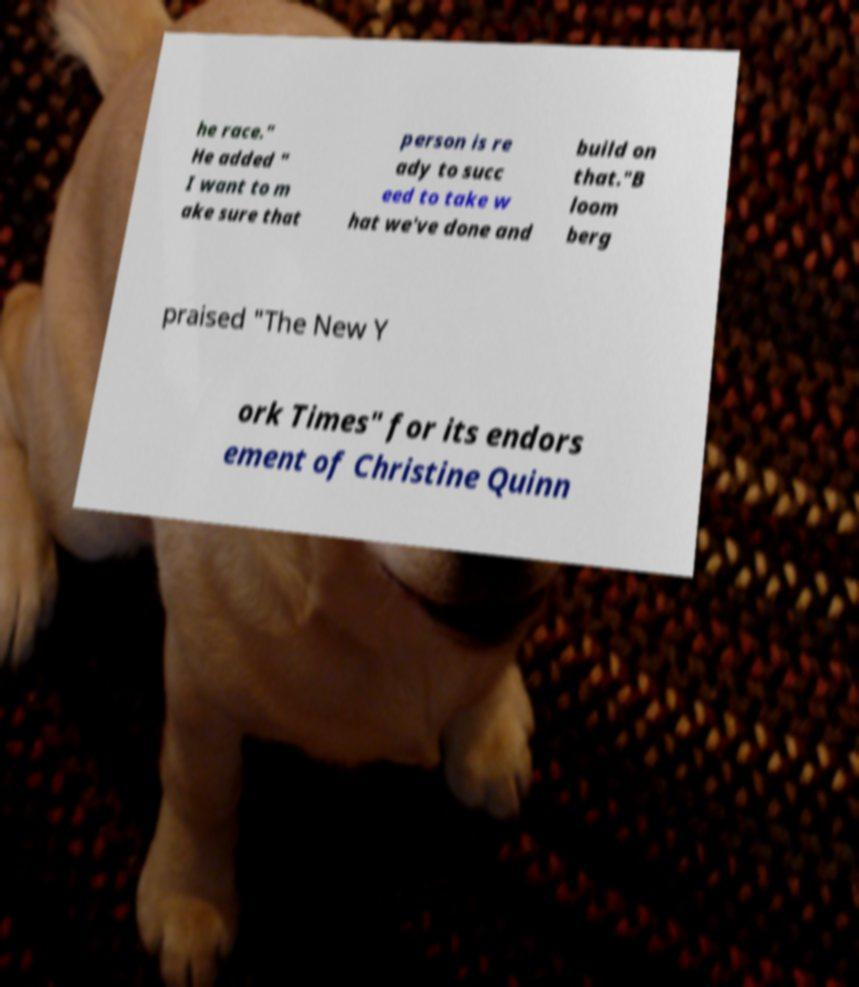Can you accurately transcribe the text from the provided image for me? he race." He added " I want to m ake sure that person is re ady to succ eed to take w hat we've done and build on that."B loom berg praised "The New Y ork Times" for its endors ement of Christine Quinn 